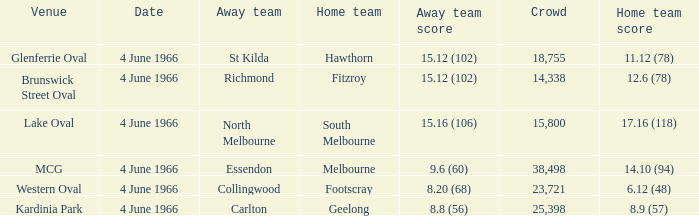What is the average crowd size of the away team who scored 9.6 (60)? 38498.0. 